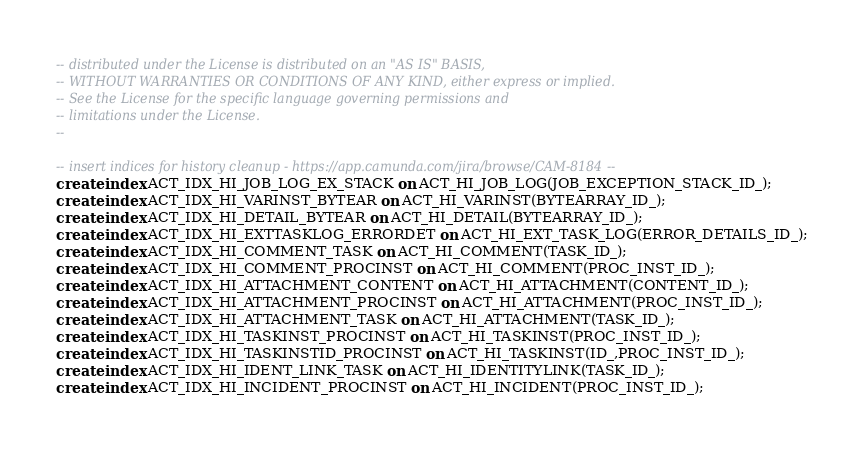<code> <loc_0><loc_0><loc_500><loc_500><_SQL_>-- distributed under the License is distributed on an "AS IS" BASIS,
-- WITHOUT WARRANTIES OR CONDITIONS OF ANY KIND, either express or implied.
-- See the License for the specific language governing permissions and
-- limitations under the License.
--

-- insert indices for history cleanup - https://app.camunda.com/jira/browse/CAM-8184 --
create index ACT_IDX_HI_JOB_LOG_EX_STACK on ACT_HI_JOB_LOG(JOB_EXCEPTION_STACK_ID_);
create index ACT_IDX_HI_VARINST_BYTEAR on ACT_HI_VARINST(BYTEARRAY_ID_);
create index ACT_IDX_HI_DETAIL_BYTEAR on ACT_HI_DETAIL(BYTEARRAY_ID_);
create index ACT_IDX_HI_EXTTASKLOG_ERRORDET on ACT_HI_EXT_TASK_LOG(ERROR_DETAILS_ID_);
create index ACT_IDX_HI_COMMENT_TASK on ACT_HI_COMMENT(TASK_ID_);
create index ACT_IDX_HI_COMMENT_PROCINST on ACT_HI_COMMENT(PROC_INST_ID_);
create index ACT_IDX_HI_ATTACHMENT_CONTENT on ACT_HI_ATTACHMENT(CONTENT_ID_);
create index ACT_IDX_HI_ATTACHMENT_PROCINST on ACT_HI_ATTACHMENT(PROC_INST_ID_);
create index ACT_IDX_HI_ATTACHMENT_TASK on ACT_HI_ATTACHMENT(TASK_ID_);
create index ACT_IDX_HI_TASKINST_PROCINST on ACT_HI_TASKINST(PROC_INST_ID_);
create index ACT_IDX_HI_TASKINSTID_PROCINST on ACT_HI_TASKINST(ID_,PROC_INST_ID_);
create index ACT_IDX_HI_IDENT_LINK_TASK on ACT_HI_IDENTITYLINK(TASK_ID_);
create index ACT_IDX_HI_INCIDENT_PROCINST on ACT_HI_INCIDENT(PROC_INST_ID_);</code> 